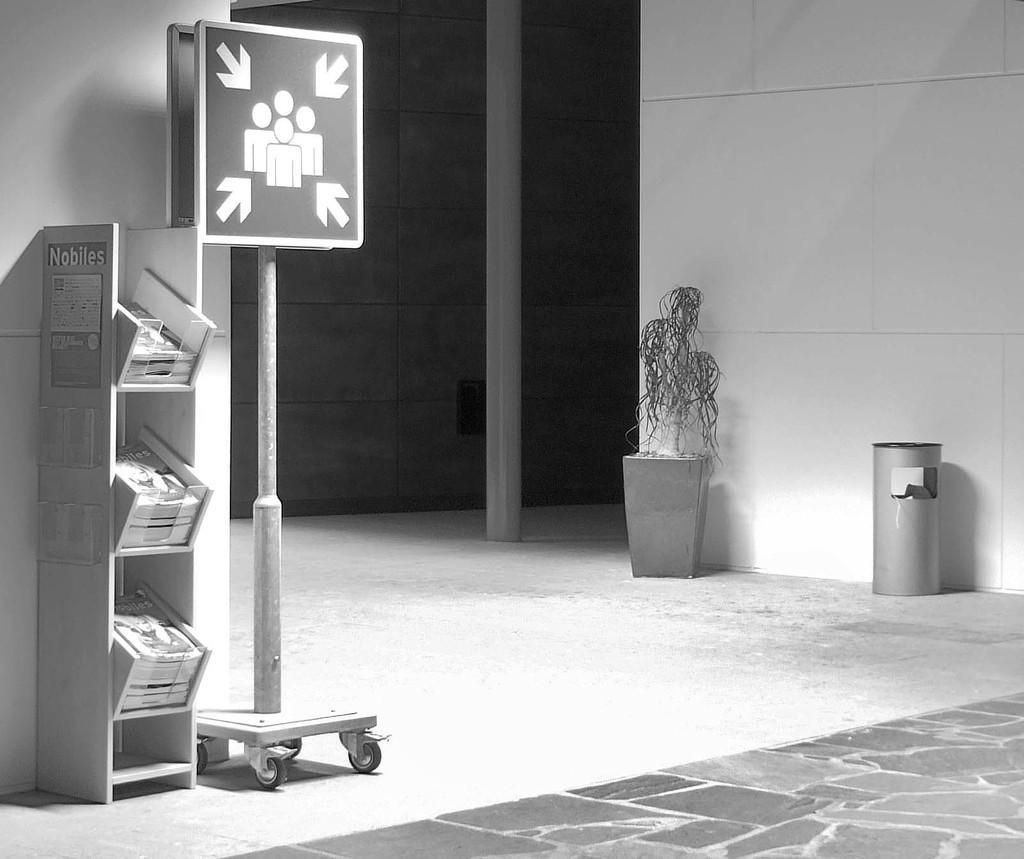Describe this image in one or two sentences. In this image there is a board. There are books on the rack. There is a flower pot and a trash can. There is a pole. There is a wall. At the bottom of the image there is a floor. 